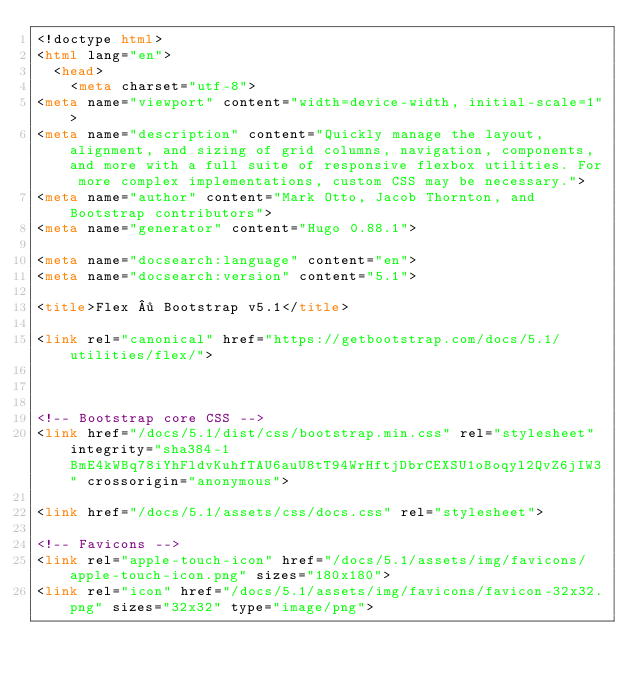Convert code to text. <code><loc_0><loc_0><loc_500><loc_500><_HTML_><!doctype html>
<html lang="en">
  <head>
    <meta charset="utf-8">
<meta name="viewport" content="width=device-width, initial-scale=1">
<meta name="description" content="Quickly manage the layout, alignment, and sizing of grid columns, navigation, components, and more with a full suite of responsive flexbox utilities. For more complex implementations, custom CSS may be necessary.">
<meta name="author" content="Mark Otto, Jacob Thornton, and Bootstrap contributors">
<meta name="generator" content="Hugo 0.88.1">

<meta name="docsearch:language" content="en">
<meta name="docsearch:version" content="5.1">

<title>Flex · Bootstrap v5.1</title>

<link rel="canonical" href="https://getbootstrap.com/docs/5.1/utilities/flex/">



<!-- Bootstrap core CSS -->
<link href="/docs/5.1/dist/css/bootstrap.min.css" rel="stylesheet" integrity="sha384-1BmE4kWBq78iYhFldvKuhfTAU6auU8tT94WrHftjDbrCEXSU1oBoqyl2QvZ6jIW3" crossorigin="anonymous">

<link href="/docs/5.1/assets/css/docs.css" rel="stylesheet">

<!-- Favicons -->
<link rel="apple-touch-icon" href="/docs/5.1/assets/img/favicons/apple-touch-icon.png" sizes="180x180">
<link rel="icon" href="/docs/5.1/assets/img/favicons/favicon-32x32.png" sizes="32x32" type="image/png"></code> 